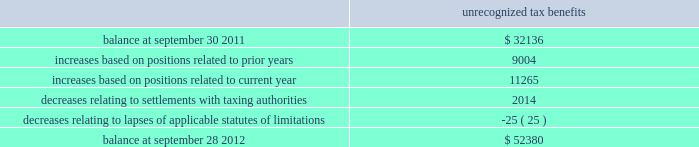Skyworks solutions , inc .
Notes to consolidated financial statements 2014 ( continued ) maintained a valuation allowance of $ 47.0 million .
This valuation allowance is comprised of $ 33.6 million related to u.s .
State tax credits , of which $ 3.6 million are state tax credits acquired from aati in fiscal year 2012 , and $ 13.4 million related to foreign deferred tax assets .
If these benefits are recognized in a future period the valuation allowance on deferred tax assets will be reversed and up to a $ 46.6 million income tax benefit , and up to a $ 0.4 million reduction to goodwill may be recognized .
The company will need to generate $ 209.0 million of future united states federal taxable income to utilize our united states deferred tax assets as of september 28 , 2012 .
Deferred tax assets are recognized for foreign operations when management believes it is more likely than not that the deferred tax assets will be recovered during the carry forward period .
The company will continue to assess its valuation allowance in future periods .
As of september 28 , 2012 , the company has united states federal net operating loss carry forwards of approximately $ 74.3 million , including $ 29.5 million related to the acquisition of sige , which will expire at various dates through 2030 and $ 28.1 million related to the acquisition of aati , which will expire at various dates through 2031 .
The utilization of these net operating losses is subject to certain annual limitations as required under internal revenue code section 382 and similar state income tax provisions .
The company also has united states federal income tax credit carry forwards of $ 37.8 million , of which $ 30.4 million of federal income tax credit carry forwards have not been recorded as a deferred tax asset .
The company also has state income tax credit carry forwards of $ 33.6 million , for which the company has provided a valuation allowance .
The united states federal tax credits expire at various dates through 2032 .
The state tax credits relate primarily to california research tax credits which can be carried forward indefinitely .
The company has continued to expand its operations and increase its investments in numerous international jurisdictions .
These activities will increase the company 2019s earnings attributable to foreign jurisdictions .
As of september 28 , 2012 , no provision has been made for united states federal , state , or additional foreign income taxes related to approximately $ 371.5 million of undistributed earnings of foreign subsidiaries which have been or are intended to be permanently reinvested .
It is not practicable to determine the united states federal income tax liability , if any , which would be payable if such earnings were not permanently reinvested .
The company 2019s gross unrecognized tax benefits totaled $ 52.4 million and $ 32.1 million as of september 28 , 2012 and september 30 , 2011 , respectively .
Of the total unrecognized tax benefits at september 28 , 2012 , $ 38.8 million would impact the effective tax rate , if recognized .
The remaining unrecognized tax benefits would not impact the effective tax rate , if recognized , due to the company 2019s valuation allowance and certain positions which were required to be capitalized .
There are no positions which the company anticipates could change within the next twelve months .
A reconciliation of the beginning and ending amount of gross unrecognized tax benefits is as follows ( in thousands ) : unrecognized tax benefits .
Page 114 annual report .
What was the percentage change in the company 2019s gross unrecognized tax benefits from 2011 to 2012? 
Computations: ((52.4 - 32.1) - 32.1)
Answer: -11.8. 